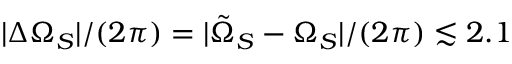Convert formula to latex. <formula><loc_0><loc_0><loc_500><loc_500>| \Delta \Omega _ { S } | / ( 2 \pi ) = | \tilde { \Omega } _ { S } - \Omega _ { S } | / ( 2 \pi ) \lesssim 2 . 1</formula> 